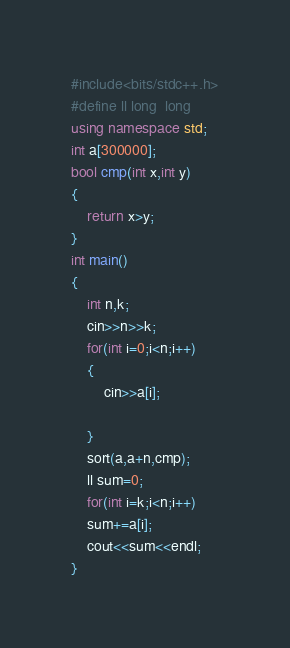<code> <loc_0><loc_0><loc_500><loc_500><_C++_>#include<bits/stdc++.h>
#define ll long  long
using namespace std;
int a[300000];
bool cmp(int x,int y)
{
	return x>y;
}
int main()
{
	int n,k;
	cin>>n>>k;
	for(int i=0;i<n;i++)
	{
		cin>>a[i];
		
	}
	sort(a,a+n,cmp);
	ll sum=0;
	for(int i=k;i<n;i++)
	sum+=a[i];
	cout<<sum<<endl;
}</code> 